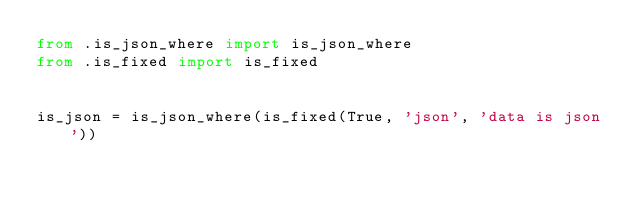Convert code to text. <code><loc_0><loc_0><loc_500><loc_500><_Python_>from .is_json_where import is_json_where
from .is_fixed import is_fixed


is_json = is_json_where(is_fixed(True, 'json', 'data is json'))
</code> 